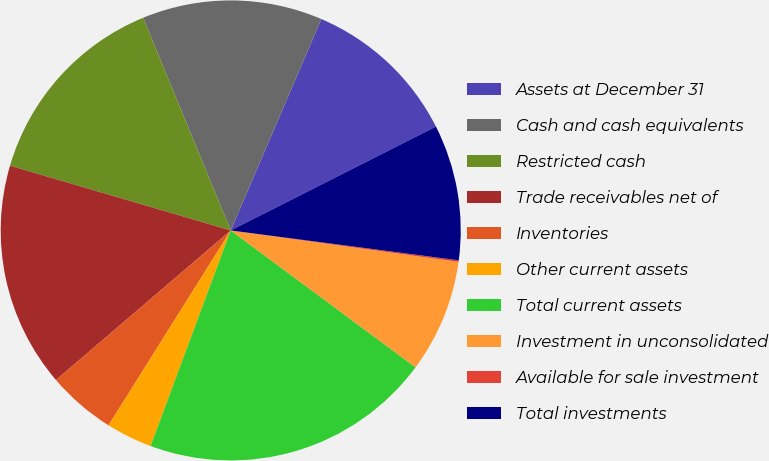Convert chart. <chart><loc_0><loc_0><loc_500><loc_500><pie_chart><fcel>Assets at December 31<fcel>Cash and cash equivalents<fcel>Restricted cash<fcel>Trade receivables net of<fcel>Inventories<fcel>Other current assets<fcel>Total current assets<fcel>Investment in unconsolidated<fcel>Available for sale investment<fcel>Total investments<nl><fcel>11.1%<fcel>12.67%<fcel>14.24%<fcel>15.81%<fcel>4.82%<fcel>3.25%<fcel>20.52%<fcel>7.96%<fcel>0.11%<fcel>9.53%<nl></chart> 